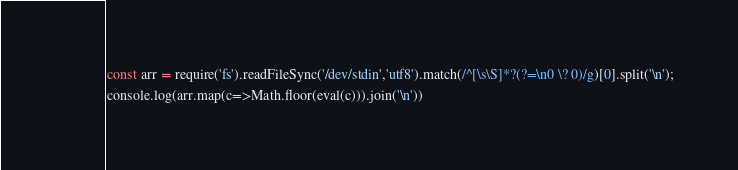Convert code to text. <code><loc_0><loc_0><loc_500><loc_500><_JavaScript_>const arr = require('fs').readFileSync('/dev/stdin','utf8').match(/^[\s\S]*?(?=\n0 \? 0)/g)[0].split('\n');
console.log(arr.map(c=>Math.floor(eval(c))).join('\n'))
</code> 